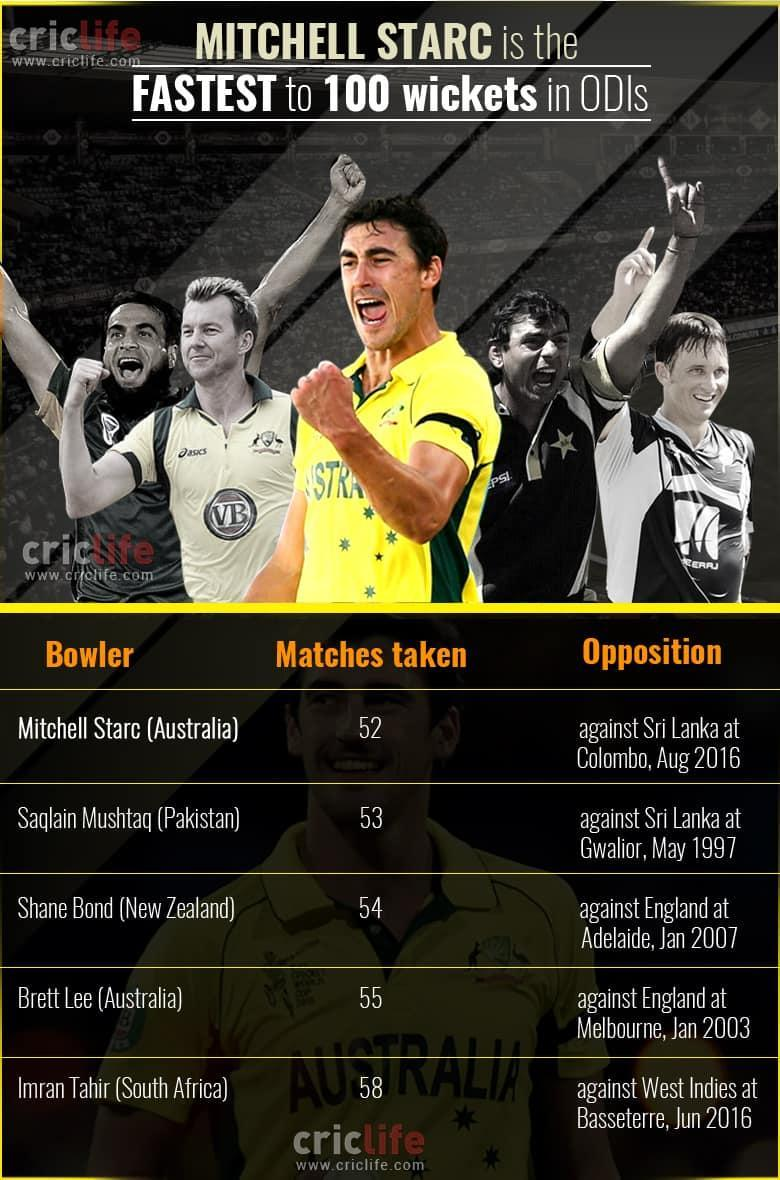how many bowlers are given in this list?
Answer the question with a short phrase. 5 who is the second fastest player to take 100 wickets in ODI? Saqlain Mushtaq(Pakistan) 